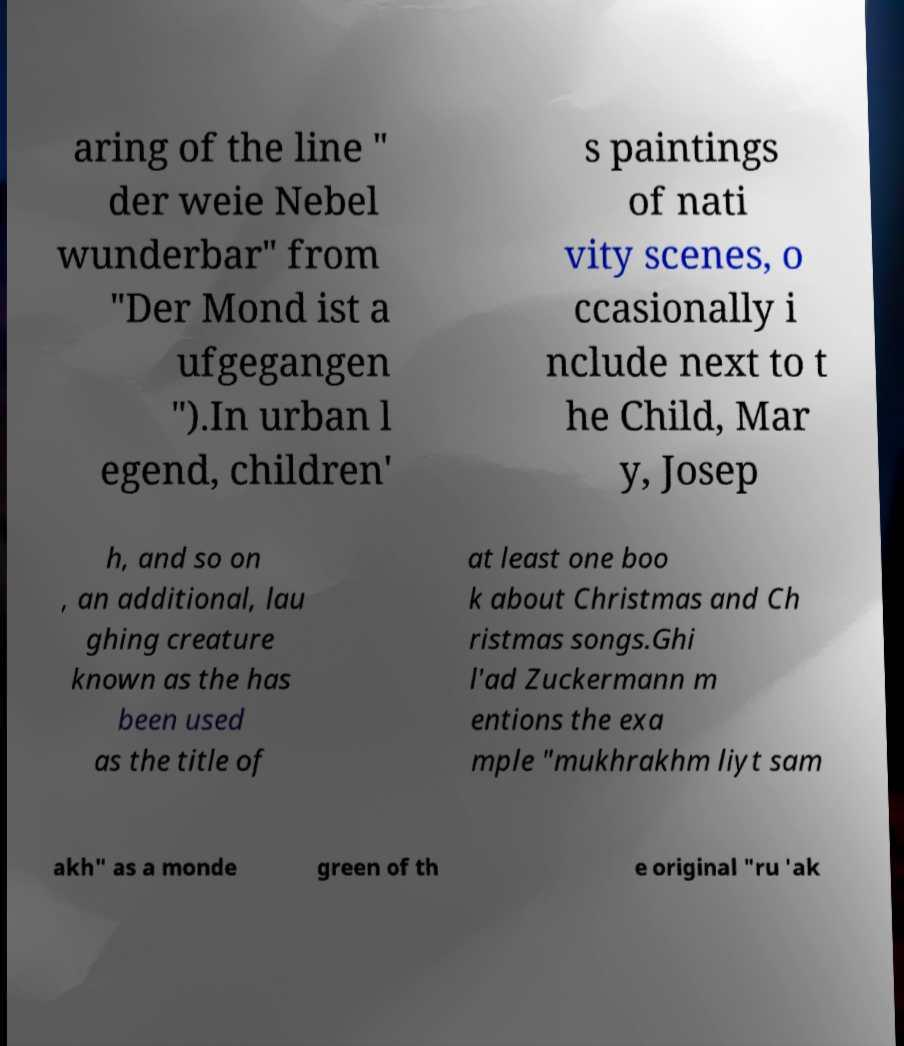Could you assist in decoding the text presented in this image and type it out clearly? aring of the line " der weie Nebel wunderbar" from "Der Mond ist a ufgegangen ").In urban l egend, children' s paintings of nati vity scenes, o ccasionally i nclude next to t he Child, Mar y, Josep h, and so on , an additional, lau ghing creature known as the has been used as the title of at least one boo k about Christmas and Ch ristmas songs.Ghi l'ad Zuckermann m entions the exa mple "mukhrakhm liyt sam akh" as a monde green of th e original "ru 'ak 